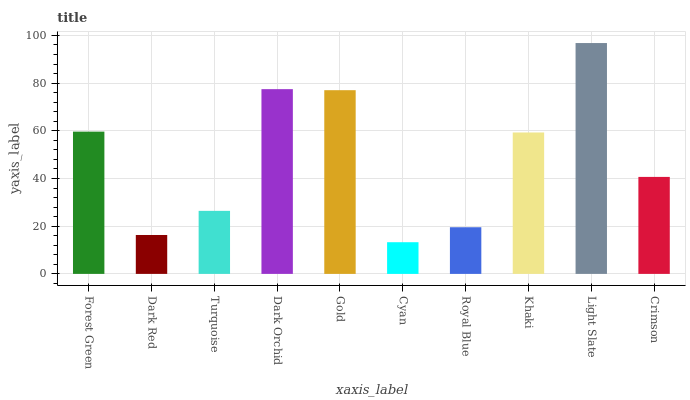Is Dark Red the minimum?
Answer yes or no. No. Is Dark Red the maximum?
Answer yes or no. No. Is Forest Green greater than Dark Red?
Answer yes or no. Yes. Is Dark Red less than Forest Green?
Answer yes or no. Yes. Is Dark Red greater than Forest Green?
Answer yes or no. No. Is Forest Green less than Dark Red?
Answer yes or no. No. Is Khaki the high median?
Answer yes or no. Yes. Is Crimson the low median?
Answer yes or no. Yes. Is Forest Green the high median?
Answer yes or no. No. Is Gold the low median?
Answer yes or no. No. 